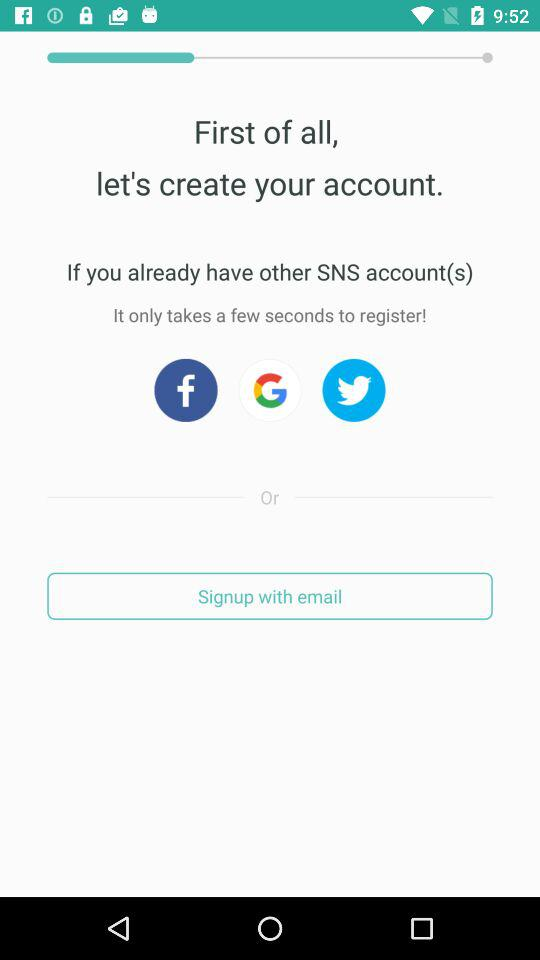Through which application can a user sign up? The user can sign up with "Facebook", "Google" and "Twitter". 